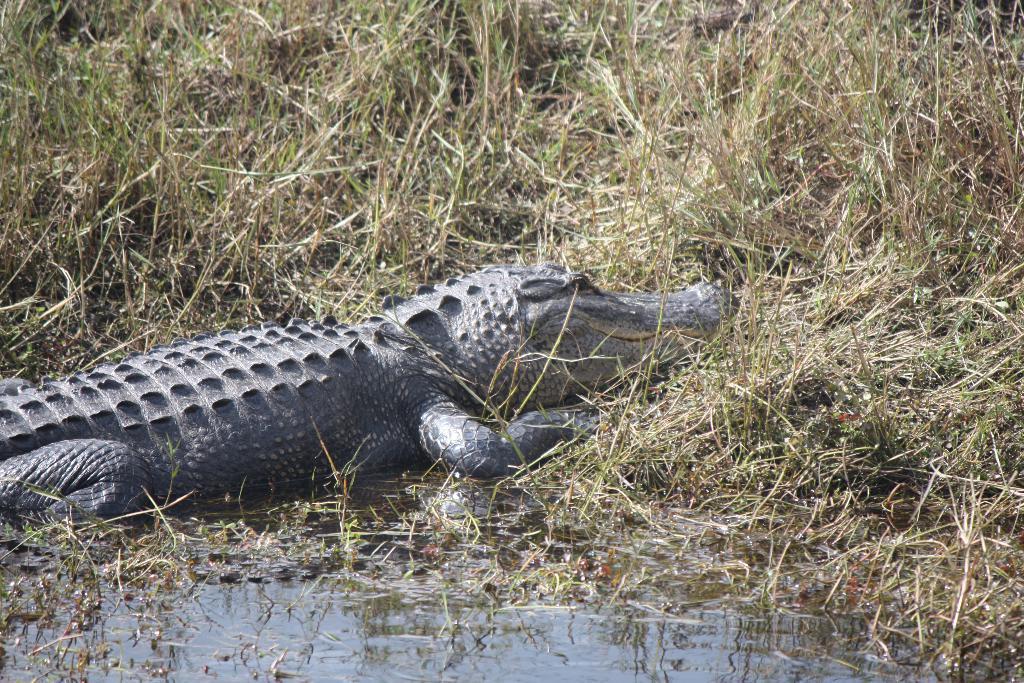In one or two sentences, can you explain what this image depicts? In this image we can see a crocodile in the water. In the background, we can see some plants. 